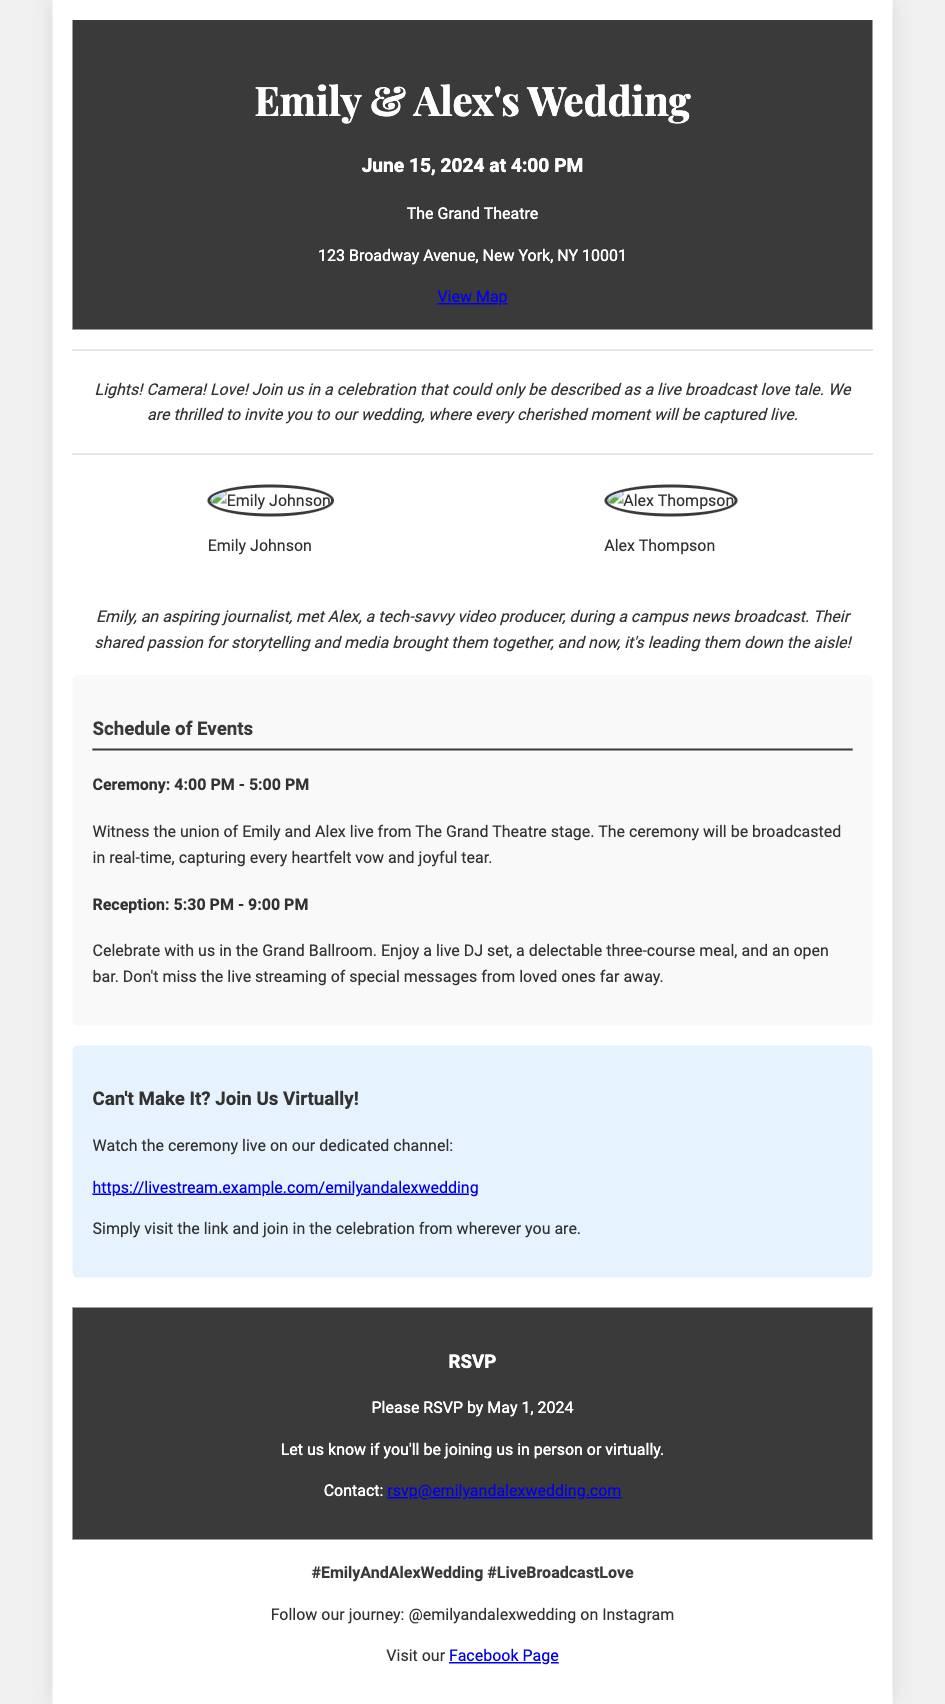What date is the wedding? The wedding date is specifically mentioned in the document under the date-time section.
Answer: June 15, 2024 What time does the wedding ceremony start? The starting time for the ceremony is highlighted in the date-time section.
Answer: 4:00 PM Where is the wedding taking place? The location of the wedding is provided within the location section.
Answer: The Grand Theatre Who is Emily's partner? Emily's partner is mentioned directly in the couple section.
Answer: Alex Thompson What is the RSVP deadline? The RSVP deadline is specified in the RSVP section of the document.
Answer: May 1, 2024 What is the unique theme of this wedding? The theme of the wedding is indicated in the welcome message.
Answer: Live Broadcast Love Tale What special feature is mentioned for attendees who cannot attend in person? The document mentions a specific feature for virtual attendees within the live-stream section.
Answer: Watch the ceremony live What is the social media handle for the wedding? The social media handle is included in the social media section of the document.
Answer: @emilyandalexwedding What types of food will be served at the reception? The food details at the reception are elaborated in the schedule of events.
Answer: Three-course meal 